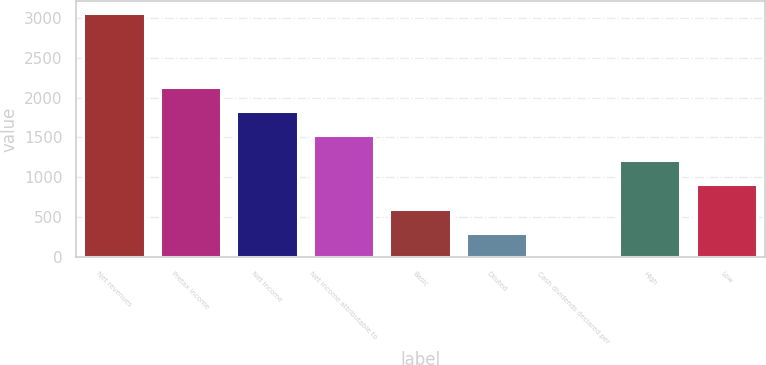Convert chart. <chart><loc_0><loc_0><loc_500><loc_500><bar_chart><fcel>Net revenues<fcel>Pretax income<fcel>Net income<fcel>Net income attributable to<fcel>Basic<fcel>Diluted<fcel>Cash dividends declared per<fcel>High<fcel>Low<nl><fcel>3053<fcel>2137.26<fcel>1832.02<fcel>1526.78<fcel>611.06<fcel>305.82<fcel>0.58<fcel>1221.54<fcel>916.3<nl></chart> 